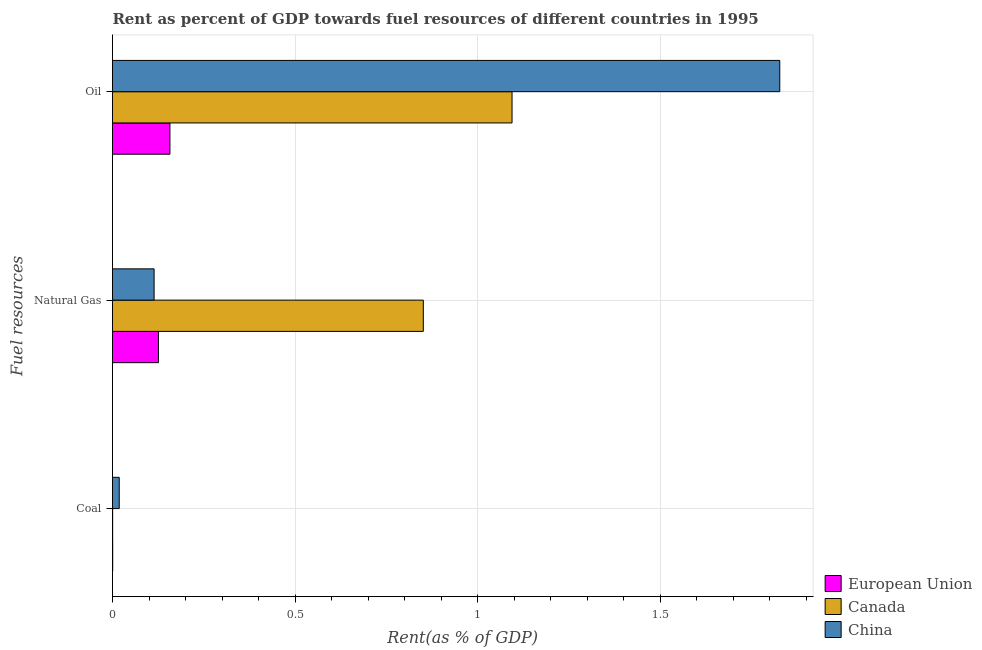How many different coloured bars are there?
Give a very brief answer. 3. Are the number of bars on each tick of the Y-axis equal?
Your response must be concise. Yes. How many bars are there on the 2nd tick from the top?
Keep it short and to the point. 3. How many bars are there on the 2nd tick from the bottom?
Your answer should be compact. 3. What is the label of the 1st group of bars from the top?
Make the answer very short. Oil. What is the rent towards oil in China?
Your answer should be very brief. 1.83. Across all countries, what is the maximum rent towards natural gas?
Offer a terse response. 0.85. Across all countries, what is the minimum rent towards oil?
Your answer should be very brief. 0.16. What is the total rent towards coal in the graph?
Ensure brevity in your answer.  0.02. What is the difference between the rent towards natural gas in Canada and that in China?
Provide a short and direct response. 0.74. What is the difference between the rent towards coal in China and the rent towards oil in European Union?
Ensure brevity in your answer.  -0.14. What is the average rent towards coal per country?
Keep it short and to the point. 0.01. What is the difference between the rent towards oil and rent towards natural gas in China?
Provide a short and direct response. 1.71. In how many countries, is the rent towards oil greater than 0.9 %?
Ensure brevity in your answer.  2. What is the ratio of the rent towards coal in Canada to that in European Union?
Provide a succinct answer. 0.75. Is the rent towards natural gas in Canada less than that in China?
Your response must be concise. No. Is the difference between the rent towards coal in China and European Union greater than the difference between the rent towards oil in China and European Union?
Make the answer very short. No. What is the difference between the highest and the second highest rent towards coal?
Your answer should be compact. 0.02. What is the difference between the highest and the lowest rent towards oil?
Your answer should be compact. 1.67. How many bars are there?
Ensure brevity in your answer.  9. Are all the bars in the graph horizontal?
Give a very brief answer. Yes. Does the graph contain grids?
Offer a terse response. Yes. How many legend labels are there?
Keep it short and to the point. 3. What is the title of the graph?
Provide a short and direct response. Rent as percent of GDP towards fuel resources of different countries in 1995. Does "Canada" appear as one of the legend labels in the graph?
Your answer should be compact. Yes. What is the label or title of the X-axis?
Provide a short and direct response. Rent(as % of GDP). What is the label or title of the Y-axis?
Your answer should be compact. Fuel resources. What is the Rent(as % of GDP) of European Union in Coal?
Provide a succinct answer. 0. What is the Rent(as % of GDP) in Canada in Coal?
Provide a succinct answer. 0. What is the Rent(as % of GDP) in China in Coal?
Keep it short and to the point. 0.02. What is the Rent(as % of GDP) in European Union in Natural Gas?
Give a very brief answer. 0.13. What is the Rent(as % of GDP) in Canada in Natural Gas?
Your answer should be compact. 0.85. What is the Rent(as % of GDP) of China in Natural Gas?
Your answer should be very brief. 0.11. What is the Rent(as % of GDP) in European Union in Oil?
Ensure brevity in your answer.  0.16. What is the Rent(as % of GDP) in Canada in Oil?
Your answer should be compact. 1.09. What is the Rent(as % of GDP) in China in Oil?
Provide a succinct answer. 1.83. Across all Fuel resources, what is the maximum Rent(as % of GDP) in European Union?
Your response must be concise. 0.16. Across all Fuel resources, what is the maximum Rent(as % of GDP) in Canada?
Provide a succinct answer. 1.09. Across all Fuel resources, what is the maximum Rent(as % of GDP) of China?
Provide a short and direct response. 1.83. Across all Fuel resources, what is the minimum Rent(as % of GDP) of European Union?
Your answer should be very brief. 0. Across all Fuel resources, what is the minimum Rent(as % of GDP) in Canada?
Provide a succinct answer. 0. Across all Fuel resources, what is the minimum Rent(as % of GDP) of China?
Provide a short and direct response. 0.02. What is the total Rent(as % of GDP) of European Union in the graph?
Your answer should be very brief. 0.28. What is the total Rent(as % of GDP) in Canada in the graph?
Your answer should be compact. 1.95. What is the total Rent(as % of GDP) of China in the graph?
Ensure brevity in your answer.  1.96. What is the difference between the Rent(as % of GDP) in European Union in Coal and that in Natural Gas?
Offer a very short reply. -0.13. What is the difference between the Rent(as % of GDP) of Canada in Coal and that in Natural Gas?
Provide a succinct answer. -0.85. What is the difference between the Rent(as % of GDP) in China in Coal and that in Natural Gas?
Offer a terse response. -0.1. What is the difference between the Rent(as % of GDP) in European Union in Coal and that in Oil?
Offer a very short reply. -0.16. What is the difference between the Rent(as % of GDP) in Canada in Coal and that in Oil?
Provide a short and direct response. -1.09. What is the difference between the Rent(as % of GDP) in China in Coal and that in Oil?
Provide a short and direct response. -1.81. What is the difference between the Rent(as % of GDP) of European Union in Natural Gas and that in Oil?
Provide a succinct answer. -0.03. What is the difference between the Rent(as % of GDP) of Canada in Natural Gas and that in Oil?
Provide a succinct answer. -0.24. What is the difference between the Rent(as % of GDP) of China in Natural Gas and that in Oil?
Your answer should be compact. -1.71. What is the difference between the Rent(as % of GDP) of European Union in Coal and the Rent(as % of GDP) of Canada in Natural Gas?
Make the answer very short. -0.85. What is the difference between the Rent(as % of GDP) of European Union in Coal and the Rent(as % of GDP) of China in Natural Gas?
Provide a succinct answer. -0.11. What is the difference between the Rent(as % of GDP) of Canada in Coal and the Rent(as % of GDP) of China in Natural Gas?
Your answer should be compact. -0.11. What is the difference between the Rent(as % of GDP) in European Union in Coal and the Rent(as % of GDP) in Canada in Oil?
Ensure brevity in your answer.  -1.09. What is the difference between the Rent(as % of GDP) in European Union in Coal and the Rent(as % of GDP) in China in Oil?
Your answer should be compact. -1.83. What is the difference between the Rent(as % of GDP) of Canada in Coal and the Rent(as % of GDP) of China in Oil?
Your response must be concise. -1.83. What is the difference between the Rent(as % of GDP) in European Union in Natural Gas and the Rent(as % of GDP) in Canada in Oil?
Offer a terse response. -0.97. What is the difference between the Rent(as % of GDP) of European Union in Natural Gas and the Rent(as % of GDP) of China in Oil?
Your response must be concise. -1.7. What is the difference between the Rent(as % of GDP) of Canada in Natural Gas and the Rent(as % of GDP) of China in Oil?
Keep it short and to the point. -0.98. What is the average Rent(as % of GDP) in European Union per Fuel resources?
Your response must be concise. 0.09. What is the average Rent(as % of GDP) in Canada per Fuel resources?
Offer a terse response. 0.65. What is the average Rent(as % of GDP) in China per Fuel resources?
Ensure brevity in your answer.  0.65. What is the difference between the Rent(as % of GDP) in European Union and Rent(as % of GDP) in China in Coal?
Offer a terse response. -0.02. What is the difference between the Rent(as % of GDP) in Canada and Rent(as % of GDP) in China in Coal?
Provide a short and direct response. -0.02. What is the difference between the Rent(as % of GDP) in European Union and Rent(as % of GDP) in Canada in Natural Gas?
Ensure brevity in your answer.  -0.73. What is the difference between the Rent(as % of GDP) of European Union and Rent(as % of GDP) of China in Natural Gas?
Make the answer very short. 0.01. What is the difference between the Rent(as % of GDP) in Canada and Rent(as % of GDP) in China in Natural Gas?
Keep it short and to the point. 0.74. What is the difference between the Rent(as % of GDP) in European Union and Rent(as % of GDP) in Canada in Oil?
Your response must be concise. -0.94. What is the difference between the Rent(as % of GDP) in European Union and Rent(as % of GDP) in China in Oil?
Provide a short and direct response. -1.67. What is the difference between the Rent(as % of GDP) in Canada and Rent(as % of GDP) in China in Oil?
Keep it short and to the point. -0.73. What is the ratio of the Rent(as % of GDP) of European Union in Coal to that in Natural Gas?
Make the answer very short. 0. What is the ratio of the Rent(as % of GDP) in China in Coal to that in Natural Gas?
Your answer should be very brief. 0.16. What is the ratio of the Rent(as % of GDP) in European Union in Coal to that in Oil?
Make the answer very short. 0. What is the ratio of the Rent(as % of GDP) in China in Coal to that in Oil?
Offer a very short reply. 0.01. What is the ratio of the Rent(as % of GDP) in European Union in Natural Gas to that in Oil?
Your response must be concise. 0.8. What is the ratio of the Rent(as % of GDP) in Canada in Natural Gas to that in Oil?
Make the answer very short. 0.78. What is the ratio of the Rent(as % of GDP) of China in Natural Gas to that in Oil?
Make the answer very short. 0.06. What is the difference between the highest and the second highest Rent(as % of GDP) of European Union?
Keep it short and to the point. 0.03. What is the difference between the highest and the second highest Rent(as % of GDP) of Canada?
Offer a terse response. 0.24. What is the difference between the highest and the second highest Rent(as % of GDP) in China?
Ensure brevity in your answer.  1.71. What is the difference between the highest and the lowest Rent(as % of GDP) of European Union?
Provide a succinct answer. 0.16. What is the difference between the highest and the lowest Rent(as % of GDP) of Canada?
Your answer should be very brief. 1.09. What is the difference between the highest and the lowest Rent(as % of GDP) of China?
Provide a short and direct response. 1.81. 